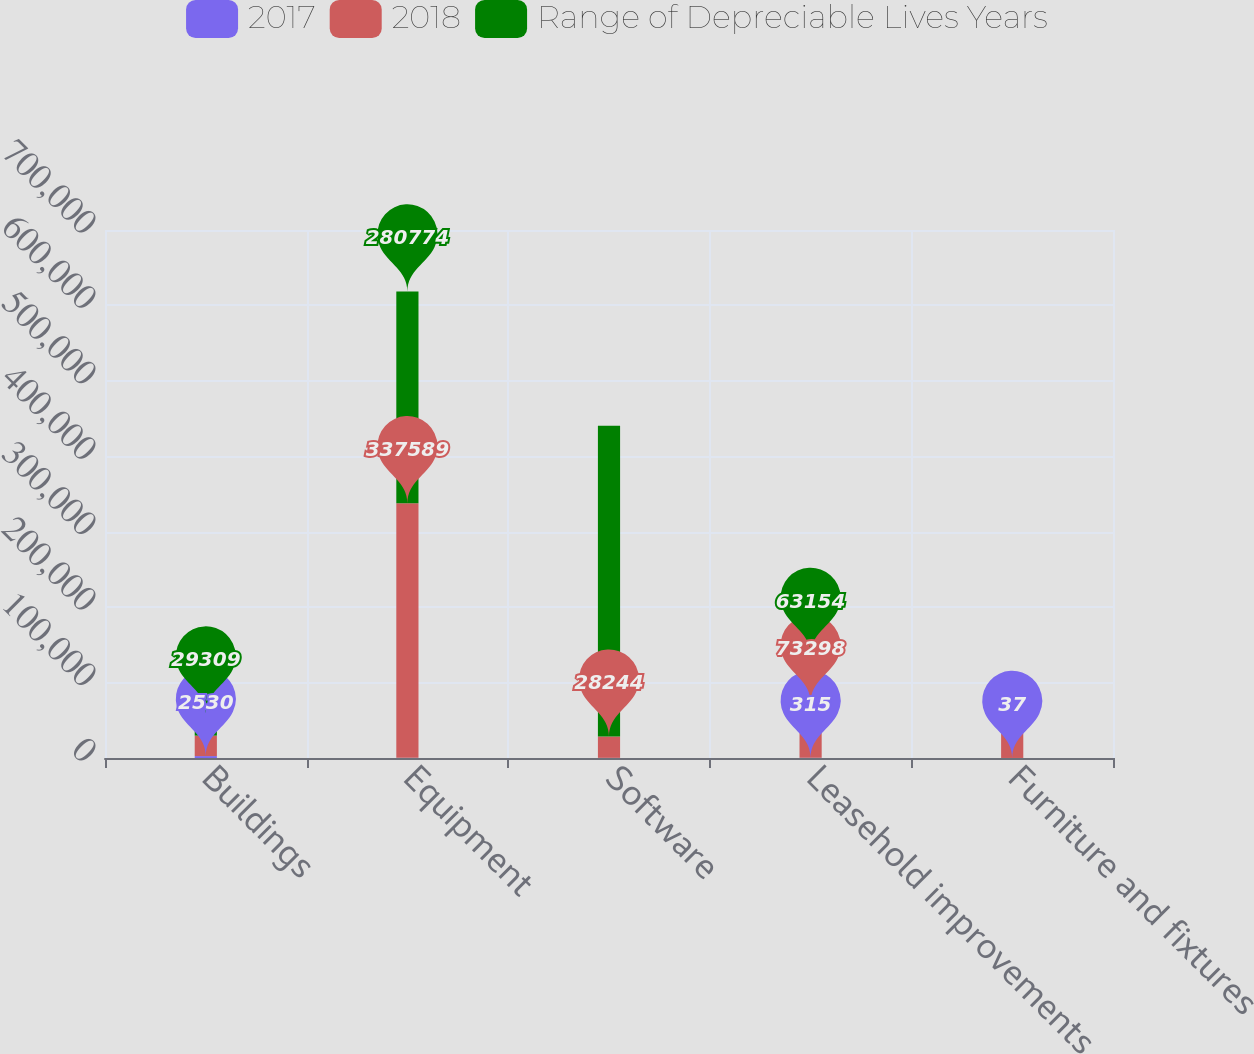<chart> <loc_0><loc_0><loc_500><loc_500><stacked_bar_chart><ecel><fcel>Buildings<fcel>Equipment<fcel>Software<fcel>Leasehold improvements<fcel>Furniture and fixtures<nl><fcel>2017<fcel>2530<fcel>220<fcel>210<fcel>315<fcel>37<nl><fcel>2018<fcel>27179<fcel>337589<fcel>28244<fcel>73298<fcel>45346<nl><fcel>Range of Depreciable Lives Years<fcel>29309<fcel>280774<fcel>411975<fcel>63154<fcel>24054<nl></chart> 